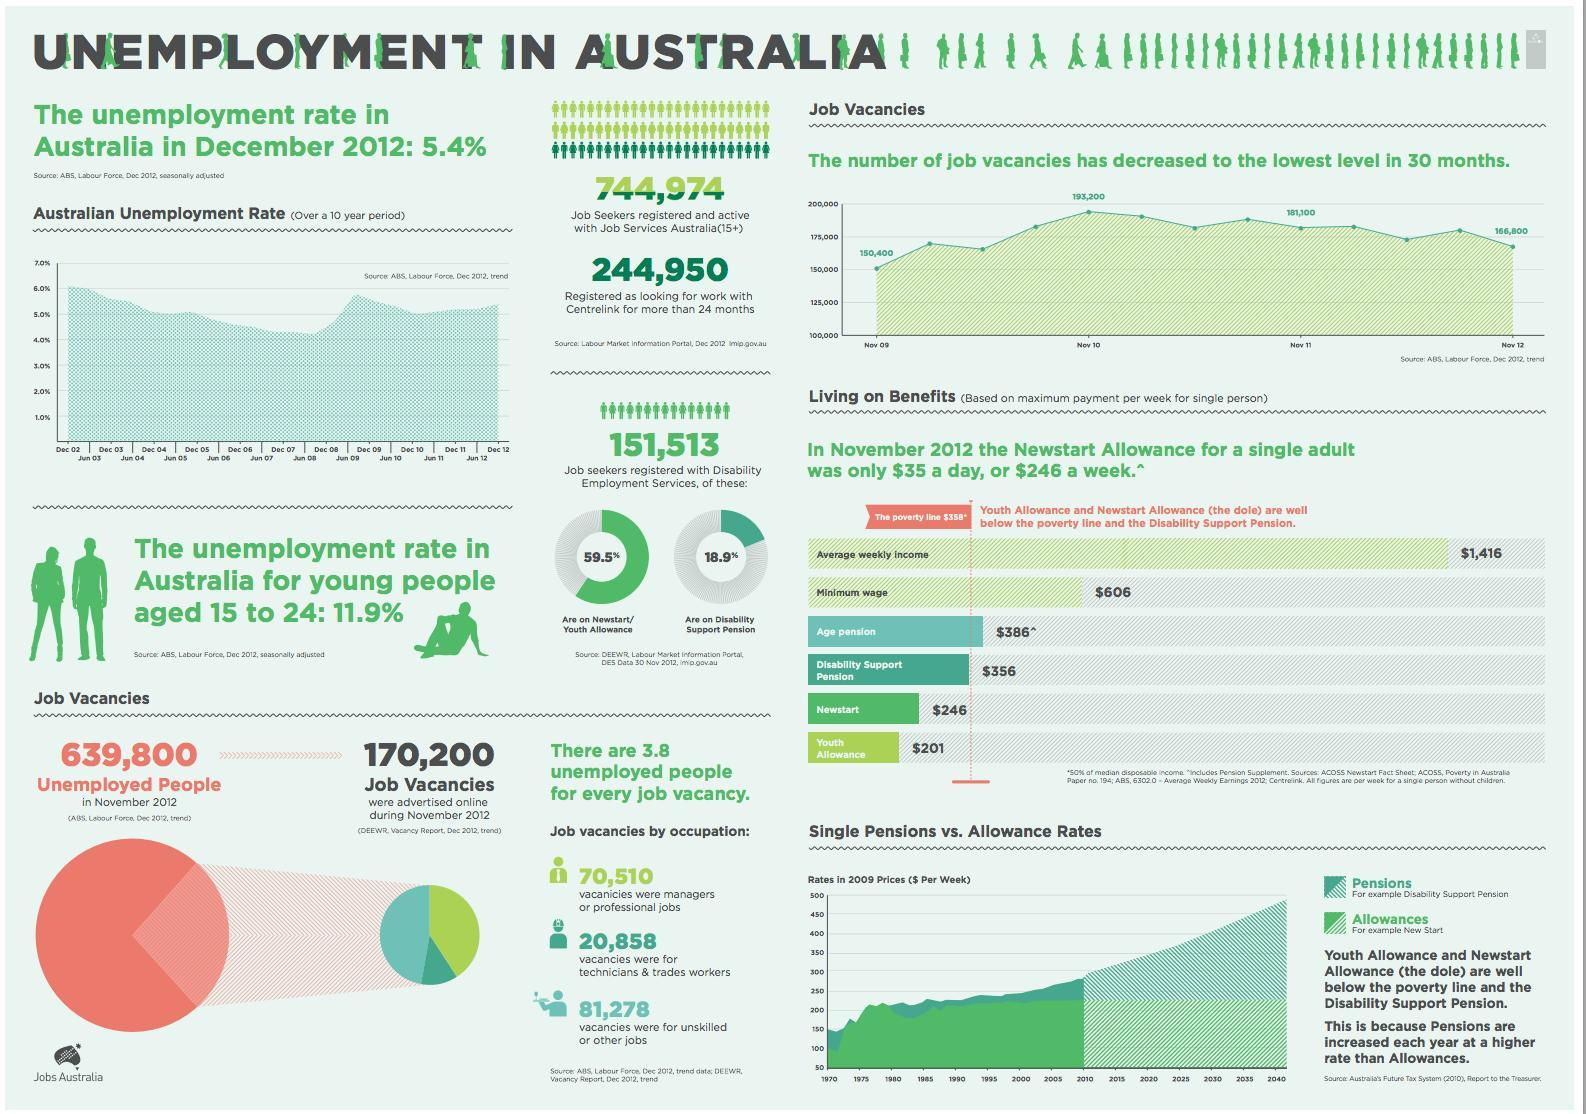What percentage of job seekers registered with Disability Employment Services are on Newstart/youth allowance in Australia in 2012?
Answer the question with a short phrase. 59.5% What percentage of job seekers registered with Disability Employment Services are on Disability Support Pension in Australia in 2012? 18.9% What is the number of vacancies for managers or professional jobs in Australia in 2012? 70,510 What is the number of vacancies for technicians & trade workers in Australia in 2012? 20,858 